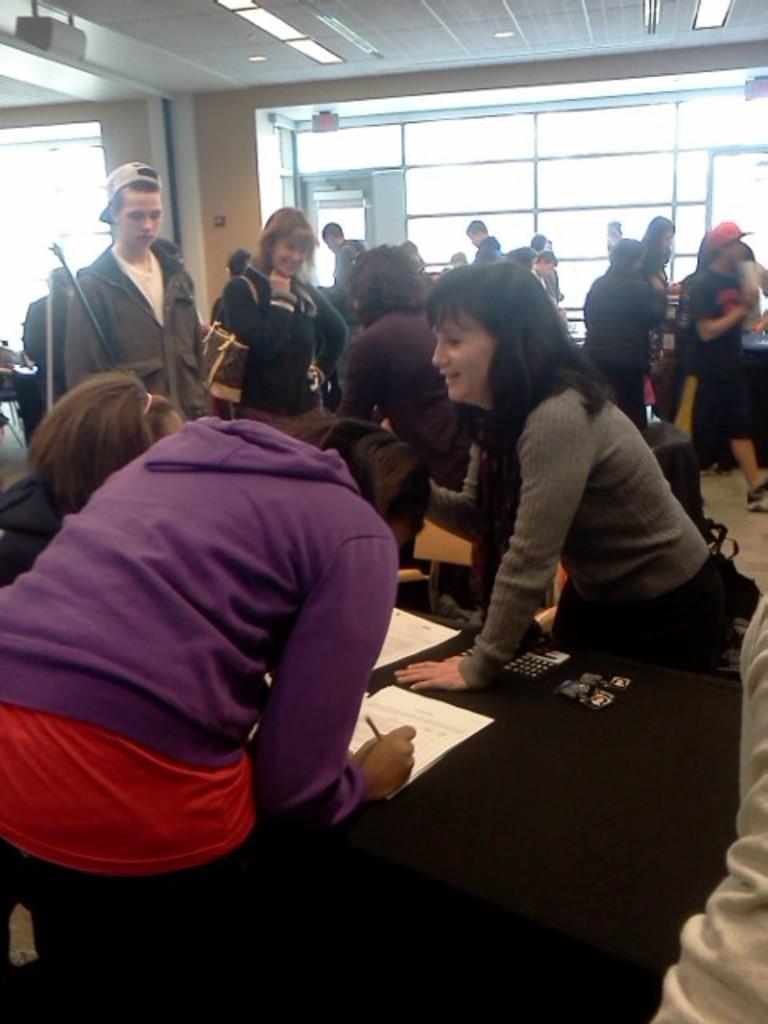Could you give a brief overview of what you see in this image? A group of people are standing on the left a girl is writing on the paper. 